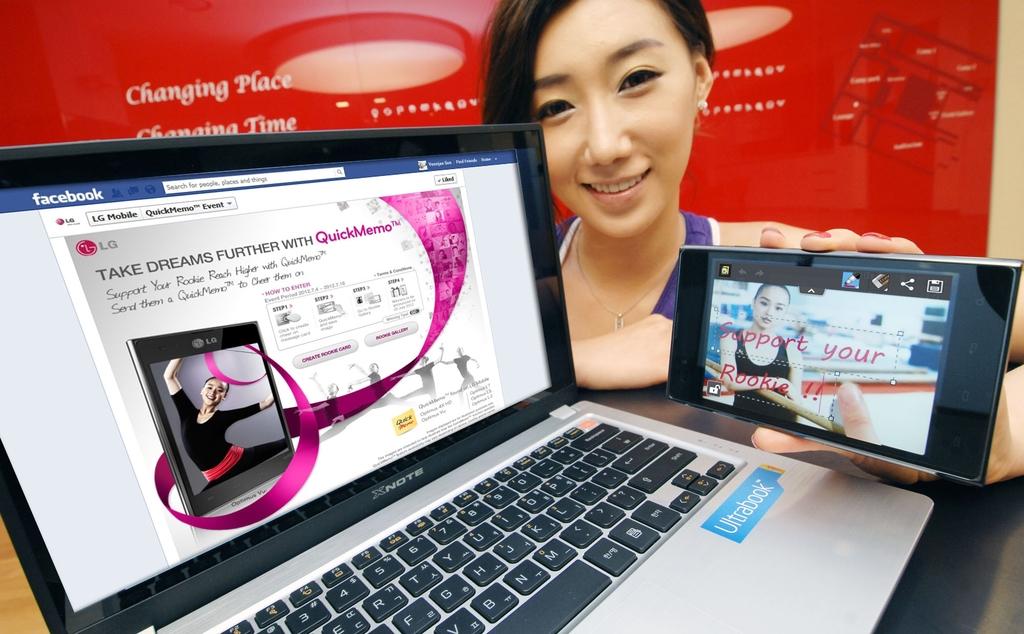What website is she on?
Offer a terse response. Facebook. What program will help you take dreams further?
Provide a short and direct response. Quickmemo. 